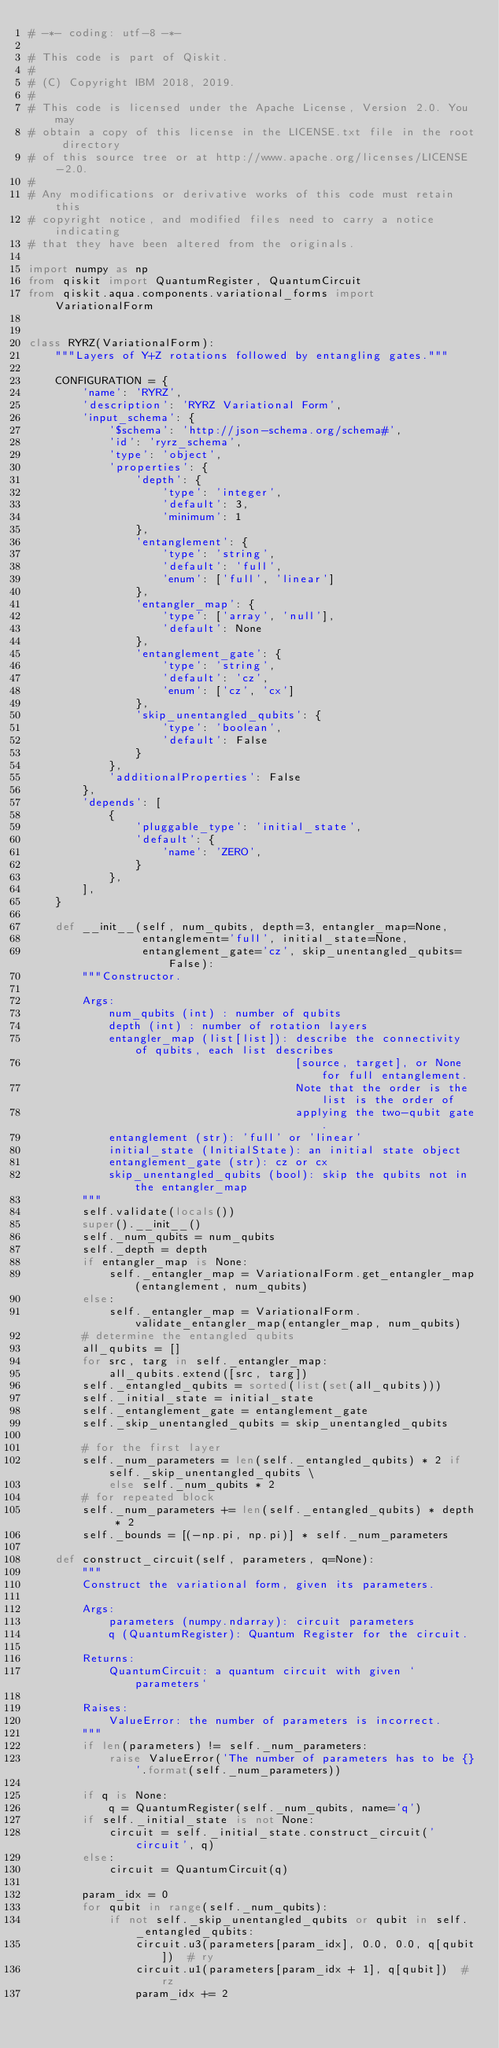<code> <loc_0><loc_0><loc_500><loc_500><_Python_># -*- coding: utf-8 -*-

# This code is part of Qiskit.
#
# (C) Copyright IBM 2018, 2019.
#
# This code is licensed under the Apache License, Version 2.0. You may
# obtain a copy of this license in the LICENSE.txt file in the root directory
# of this source tree or at http://www.apache.org/licenses/LICENSE-2.0.
#
# Any modifications or derivative works of this code must retain this
# copyright notice, and modified files need to carry a notice indicating
# that they have been altered from the originals.

import numpy as np
from qiskit import QuantumRegister, QuantumCircuit
from qiskit.aqua.components.variational_forms import VariationalForm


class RYRZ(VariationalForm):
    """Layers of Y+Z rotations followed by entangling gates."""

    CONFIGURATION = {
        'name': 'RYRZ',
        'description': 'RYRZ Variational Form',
        'input_schema': {
            '$schema': 'http://json-schema.org/schema#',
            'id': 'ryrz_schema',
            'type': 'object',
            'properties': {
                'depth': {
                    'type': 'integer',
                    'default': 3,
                    'minimum': 1
                },
                'entanglement': {
                    'type': 'string',
                    'default': 'full',
                    'enum': ['full', 'linear']
                },
                'entangler_map': {
                    'type': ['array', 'null'],
                    'default': None
                },
                'entanglement_gate': {
                    'type': 'string',
                    'default': 'cz',
                    'enum': ['cz', 'cx']
                },
                'skip_unentangled_qubits': {
                    'type': 'boolean',
                    'default': False
                }
            },
            'additionalProperties': False
        },
        'depends': [
            {
                'pluggable_type': 'initial_state',
                'default': {
                    'name': 'ZERO',
                }
            },
        ],
    }

    def __init__(self, num_qubits, depth=3, entangler_map=None,
                 entanglement='full', initial_state=None,
                 entanglement_gate='cz', skip_unentangled_qubits=False):
        """Constructor.

        Args:
            num_qubits (int) : number of qubits
            depth (int) : number of rotation layers
            entangler_map (list[list]): describe the connectivity of qubits, each list describes
                                        [source, target], or None for full entanglement.
                                        Note that the order is the list is the order of
                                        applying the two-qubit gate.
            entanglement (str): 'full' or 'linear'
            initial_state (InitialState): an initial state object
            entanglement_gate (str): cz or cx
            skip_unentangled_qubits (bool): skip the qubits not in the entangler_map
        """
        self.validate(locals())
        super().__init__()
        self._num_qubits = num_qubits
        self._depth = depth
        if entangler_map is None:
            self._entangler_map = VariationalForm.get_entangler_map(entanglement, num_qubits)
        else:
            self._entangler_map = VariationalForm.validate_entangler_map(entangler_map, num_qubits)
        # determine the entangled qubits
        all_qubits = []
        for src, targ in self._entangler_map:
            all_qubits.extend([src, targ])
        self._entangled_qubits = sorted(list(set(all_qubits)))
        self._initial_state = initial_state
        self._entanglement_gate = entanglement_gate
        self._skip_unentangled_qubits = skip_unentangled_qubits

        # for the first layer
        self._num_parameters = len(self._entangled_qubits) * 2 if self._skip_unentangled_qubits \
            else self._num_qubits * 2
        # for repeated block
        self._num_parameters += len(self._entangled_qubits) * depth * 2
        self._bounds = [(-np.pi, np.pi)] * self._num_parameters

    def construct_circuit(self, parameters, q=None):
        """
        Construct the variational form, given its parameters.

        Args:
            parameters (numpy.ndarray): circuit parameters
            q (QuantumRegister): Quantum Register for the circuit.

        Returns:
            QuantumCircuit: a quantum circuit with given `parameters`

        Raises:
            ValueError: the number of parameters is incorrect.
        """
        if len(parameters) != self._num_parameters:
            raise ValueError('The number of parameters has to be {}'.format(self._num_parameters))

        if q is None:
            q = QuantumRegister(self._num_qubits, name='q')
        if self._initial_state is not None:
            circuit = self._initial_state.construct_circuit('circuit', q)
        else:
            circuit = QuantumCircuit(q)

        param_idx = 0
        for qubit in range(self._num_qubits):
            if not self._skip_unentangled_qubits or qubit in self._entangled_qubits:
                circuit.u3(parameters[param_idx], 0.0, 0.0, q[qubit])  # ry
                circuit.u1(parameters[param_idx + 1], q[qubit])  # rz
                param_idx += 2
</code> 